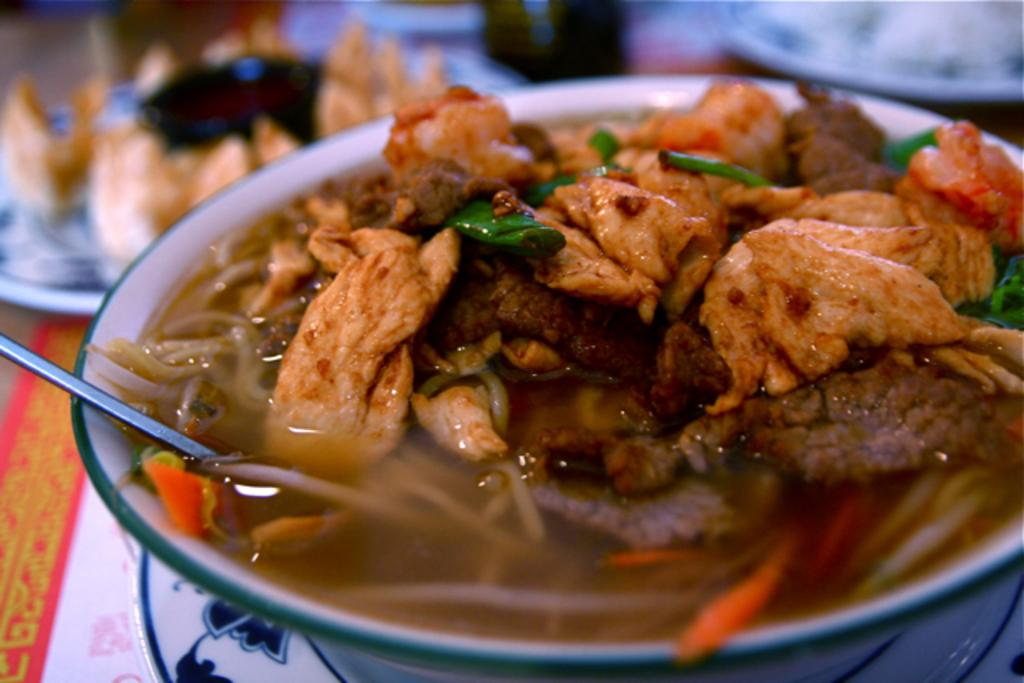What type of food can be seen in the image? The food in the image has brown, cream, and green colors. How is the food presented in the image? The food is in a bowl. What color is the bowl? The bowl is white. Can you describe the background of the image? The background of the image is blurred. What type of line can be seen on the paper in the image? There is no paper or line present in the image; it features food in a white bowl with a blurred background. 